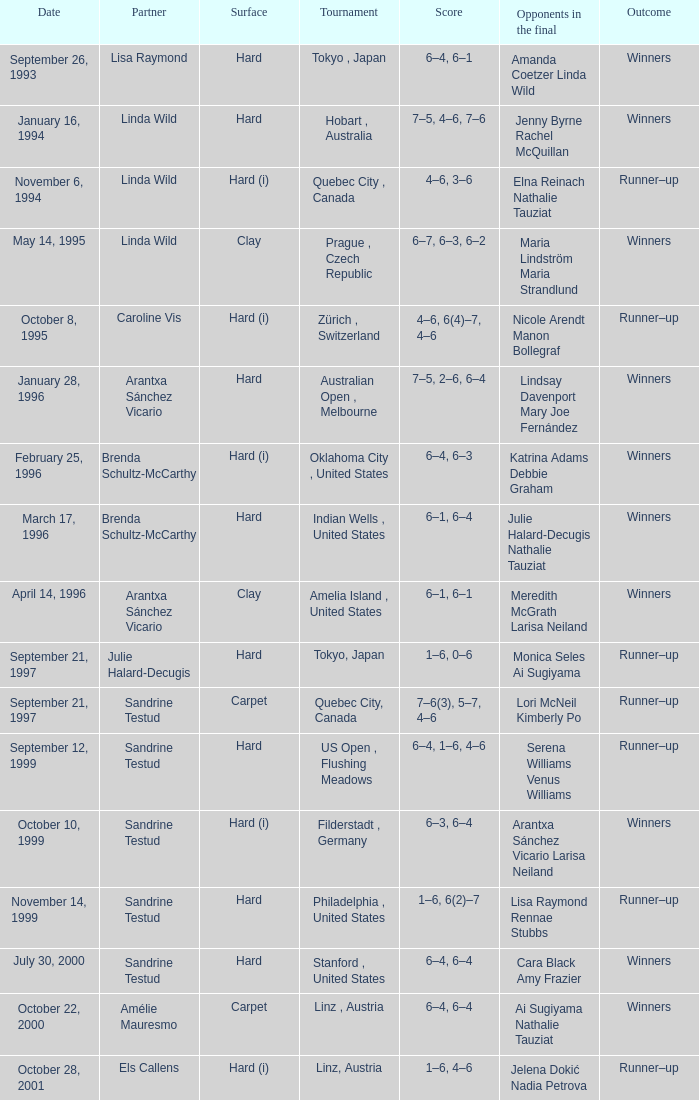Which surface had a partner of Sandrine Testud on November 14, 1999? Hard. 